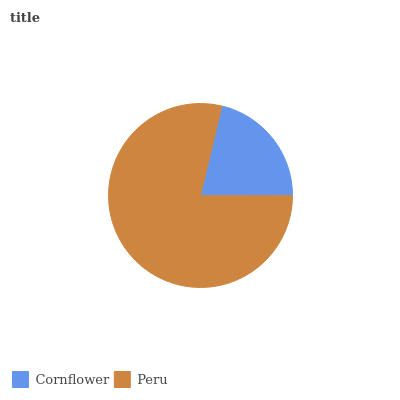Is Cornflower the minimum?
Answer yes or no. Yes. Is Peru the maximum?
Answer yes or no. Yes. Is Peru the minimum?
Answer yes or no. No. Is Peru greater than Cornflower?
Answer yes or no. Yes. Is Cornflower less than Peru?
Answer yes or no. Yes. Is Cornflower greater than Peru?
Answer yes or no. No. Is Peru less than Cornflower?
Answer yes or no. No. Is Peru the high median?
Answer yes or no. Yes. Is Cornflower the low median?
Answer yes or no. Yes. Is Cornflower the high median?
Answer yes or no. No. Is Peru the low median?
Answer yes or no. No. 